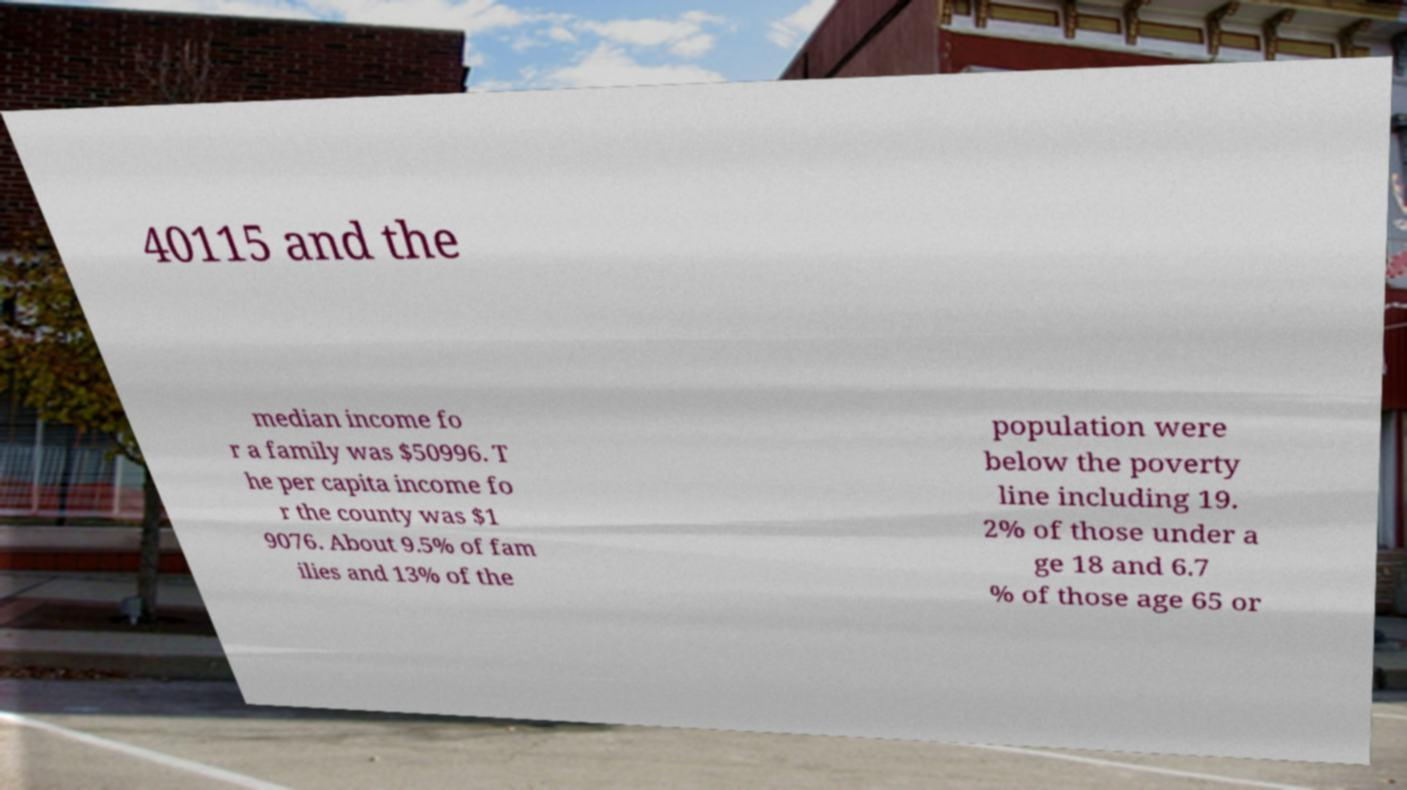There's text embedded in this image that I need extracted. Can you transcribe it verbatim? 40115 and the median income fo r a family was $50996. T he per capita income fo r the county was $1 9076. About 9.5% of fam ilies and 13% of the population were below the poverty line including 19. 2% of those under a ge 18 and 6.7 % of those age 65 or 